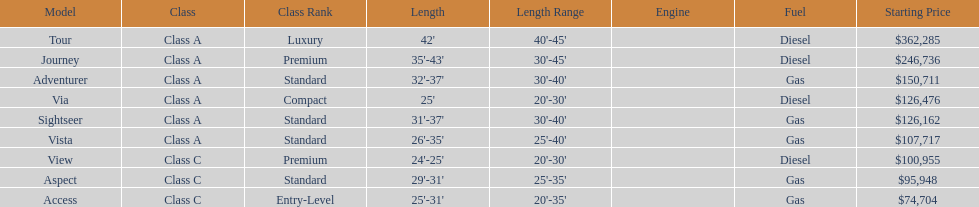Which models are manufactured by winnebago industries? Tour, Journey, Adventurer, Via, Sightseer, Vista, View, Aspect, Access. What type of fuel does each model require? Diesel, Diesel, Gas, Diesel, Gas, Gas, Diesel, Gas, Gas. And between the tour and aspect, which runs on diesel? Tour. 